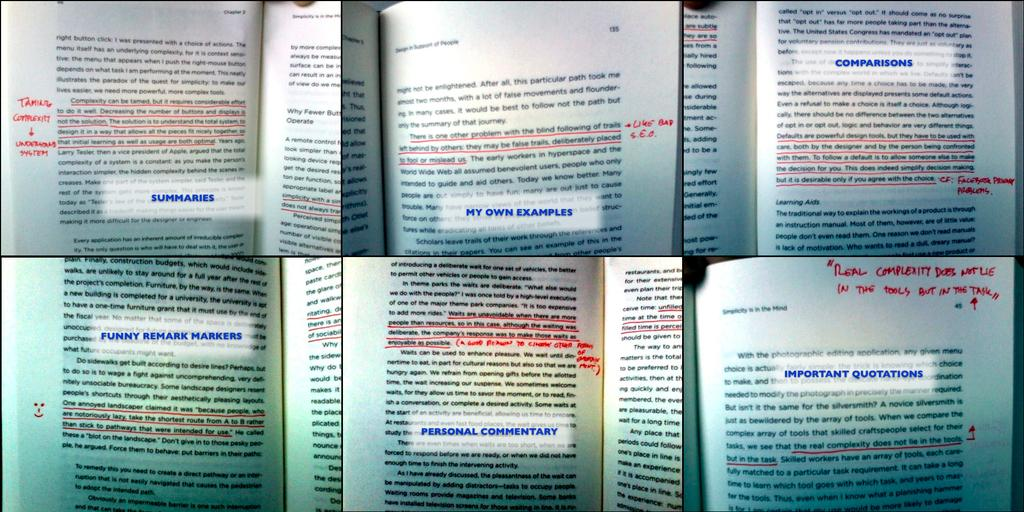<image>
Provide a brief description of the given image. Different pages of writing one which is titled summaries. 